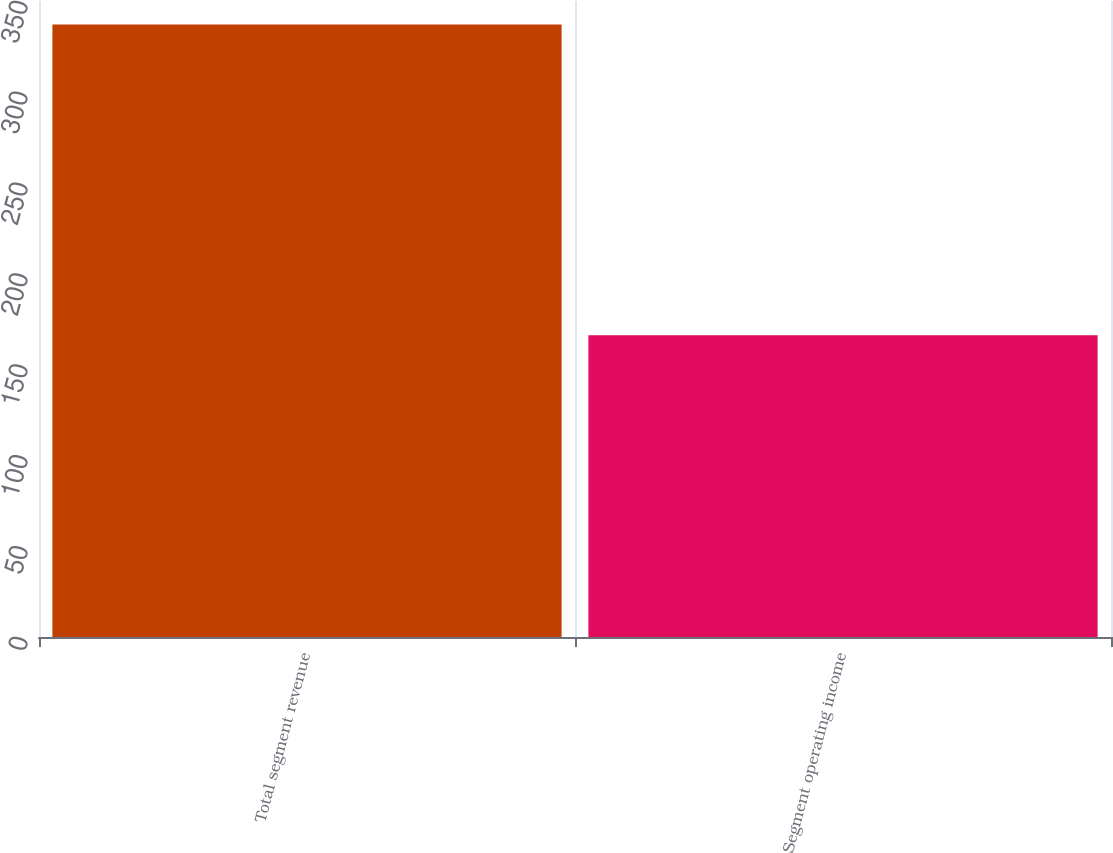Convert chart. <chart><loc_0><loc_0><loc_500><loc_500><bar_chart><fcel>Total segment revenue<fcel>Segment operating income<nl><fcel>337<fcel>166<nl></chart> 